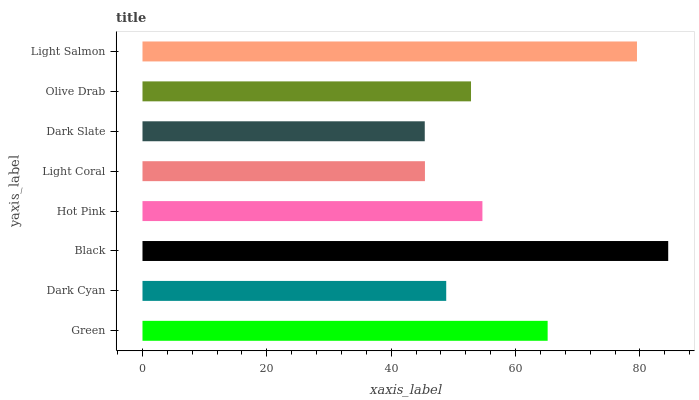Is Dark Slate the minimum?
Answer yes or no. Yes. Is Black the maximum?
Answer yes or no. Yes. Is Dark Cyan the minimum?
Answer yes or no. No. Is Dark Cyan the maximum?
Answer yes or no. No. Is Green greater than Dark Cyan?
Answer yes or no. Yes. Is Dark Cyan less than Green?
Answer yes or no. Yes. Is Dark Cyan greater than Green?
Answer yes or no. No. Is Green less than Dark Cyan?
Answer yes or no. No. Is Hot Pink the high median?
Answer yes or no. Yes. Is Olive Drab the low median?
Answer yes or no. Yes. Is Dark Cyan the high median?
Answer yes or no. No. Is Green the low median?
Answer yes or no. No. 